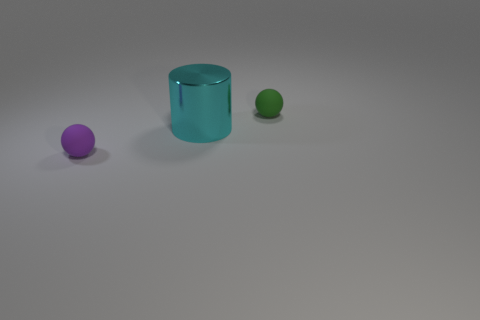There is a small rubber ball that is on the right side of the cyan metal cylinder; how many small balls are in front of it? 1 